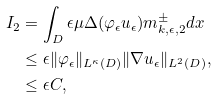<formula> <loc_0><loc_0><loc_500><loc_500>I _ { 2 } & = \int _ { D } \epsilon \mu \Delta ( \varphi _ { \epsilon } u _ { \epsilon } ) m _ { k , \epsilon , 2 } ^ { \pm } d x \\ & \leq \epsilon \| \varphi _ { \epsilon } \| _ { L ^ { \kappa } ( D ) } \| \nabla u _ { \epsilon } \| _ { L ^ { 2 } ( D ) } , \\ & \leq \epsilon C ,</formula> 